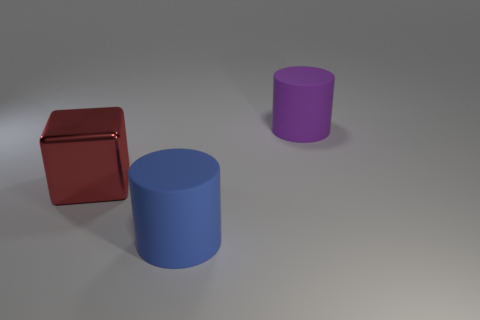Can you tell me the colors of the cylinders? Certainly! In the image, one cylinder appears to be blue, while the other is purple. 